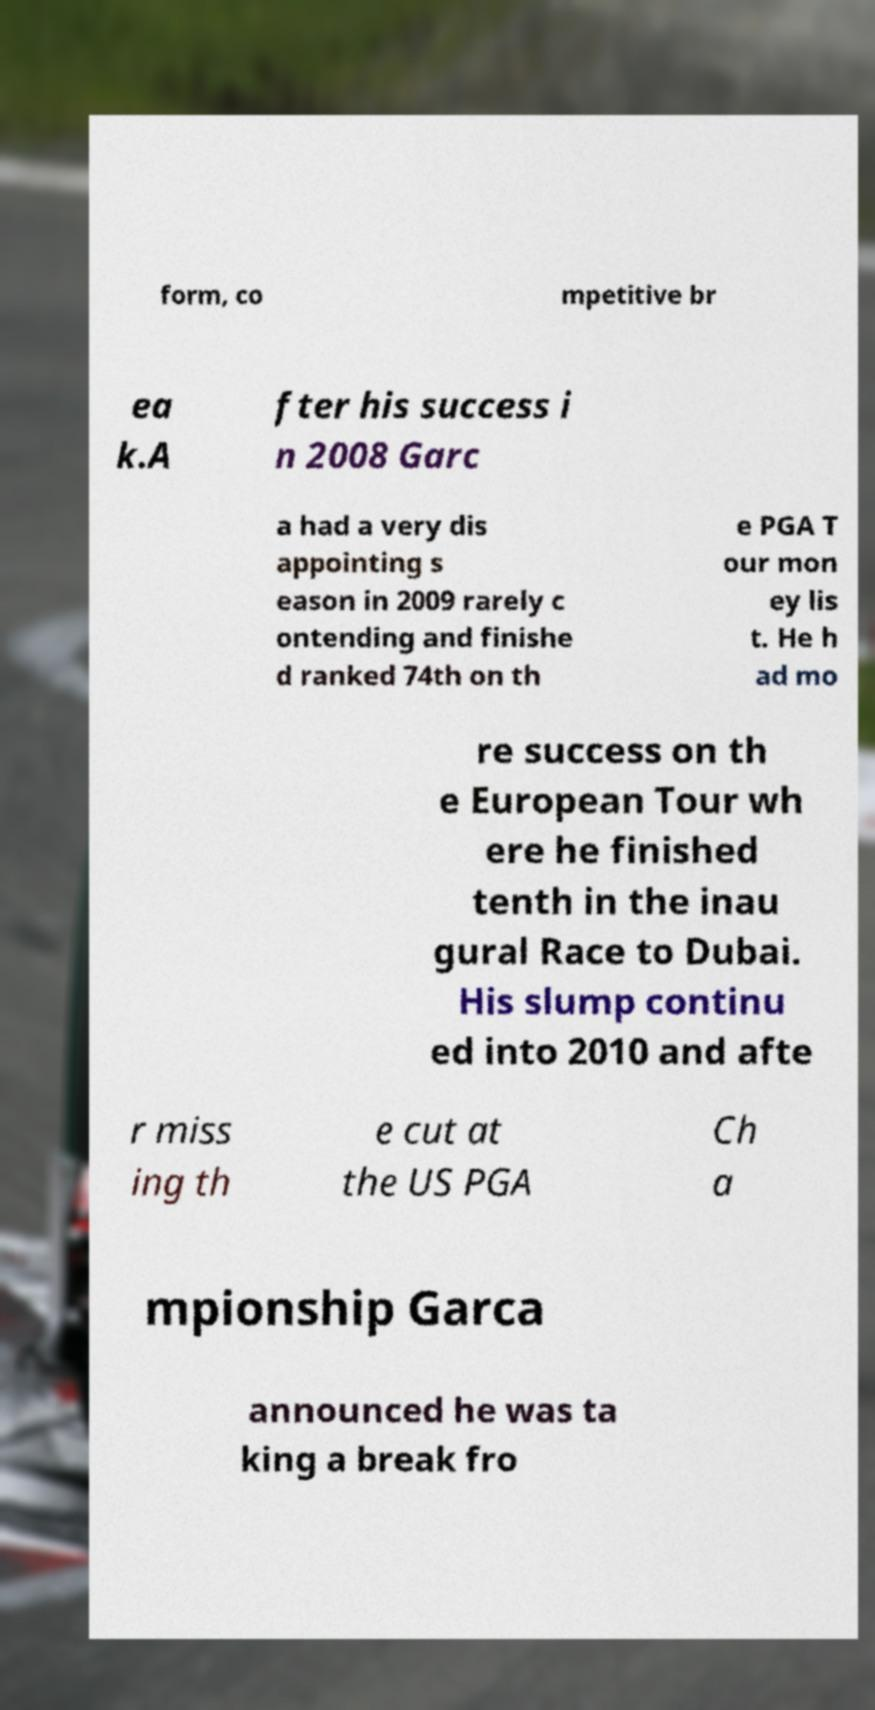What messages or text are displayed in this image? I need them in a readable, typed format. form, co mpetitive br ea k.A fter his success i n 2008 Garc a had a very dis appointing s eason in 2009 rarely c ontending and finishe d ranked 74th on th e PGA T our mon ey lis t. He h ad mo re success on th e European Tour wh ere he finished tenth in the inau gural Race to Dubai. His slump continu ed into 2010 and afte r miss ing th e cut at the US PGA Ch a mpionship Garca announced he was ta king a break fro 